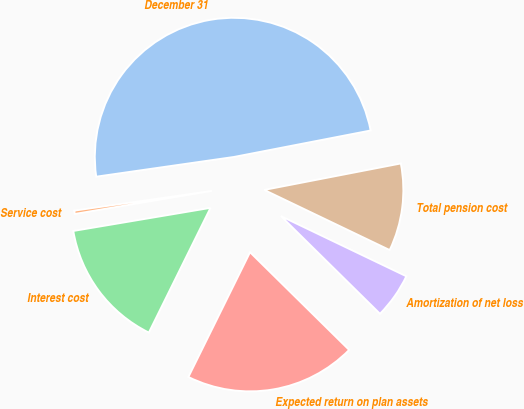Convert chart to OTSL. <chart><loc_0><loc_0><loc_500><loc_500><pie_chart><fcel>December 31<fcel>Service cost<fcel>Interest cost<fcel>Expected return on plan assets<fcel>Amortization of net loss<fcel>Total pension cost<nl><fcel>49.22%<fcel>0.39%<fcel>15.04%<fcel>19.92%<fcel>5.27%<fcel>10.16%<nl></chart> 